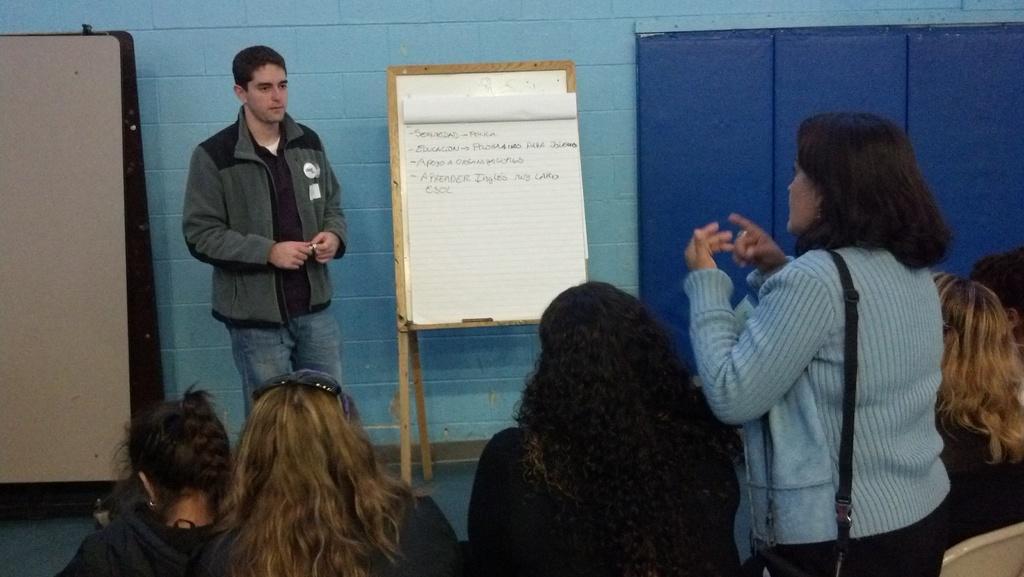Could you give a brief overview of what you see in this image? In the image in the center we can see one person standing and holding some object. In the bottom of the image we can see few people were sitting on the chair and one woman standing. In the background we can see wall,boards and cupboards. 